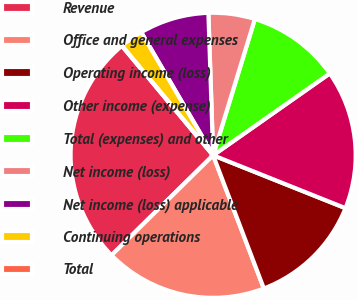<chart> <loc_0><loc_0><loc_500><loc_500><pie_chart><fcel>Revenue<fcel>Office and general expenses<fcel>Operating income (loss)<fcel>Other income (expense)<fcel>Total (expenses) and other<fcel>Net income (loss)<fcel>Net income (loss) applicable<fcel>Continuing operations<fcel>Total<nl><fcel>26.32%<fcel>18.42%<fcel>13.16%<fcel>15.79%<fcel>10.53%<fcel>5.26%<fcel>7.89%<fcel>2.63%<fcel>0.0%<nl></chart> 